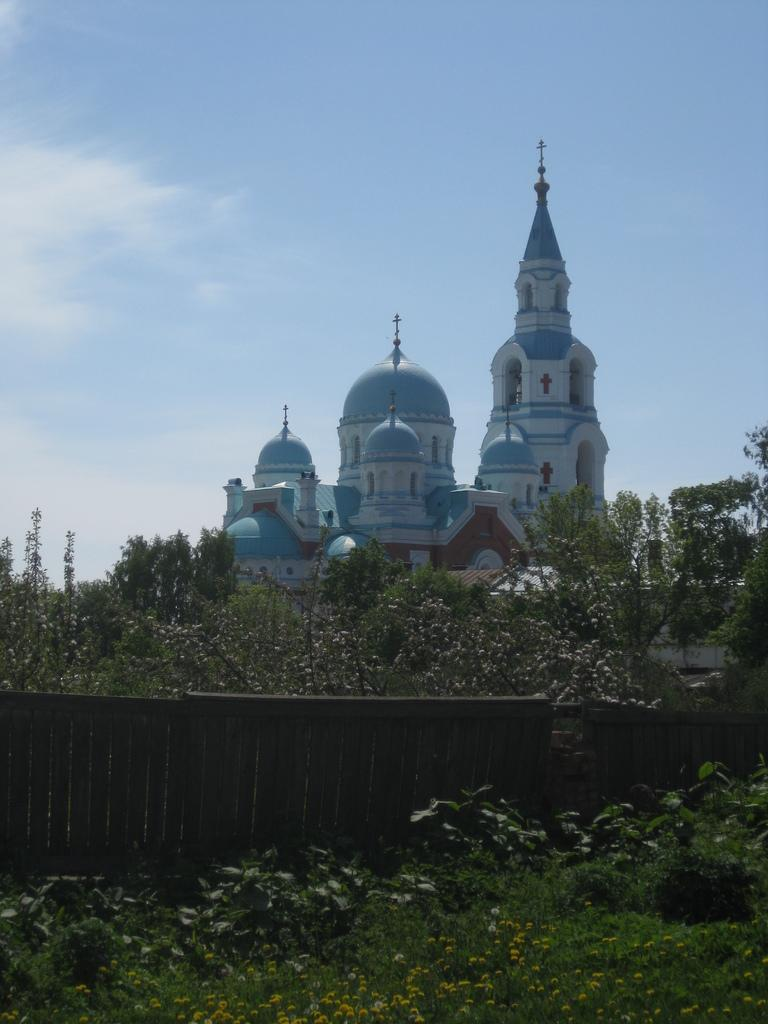What type of vegetation can be seen in the image? There is grass, plants, and trees in the image. What structures are present in the image? There is a wall and a building in the image. What part of the natural environment is visible in the image? The sky is visible in the image. How many passengers are visible in the image? There are no passengers present in the image. What type of sign can be seen in the image? There is no text or sign visible in the image. 